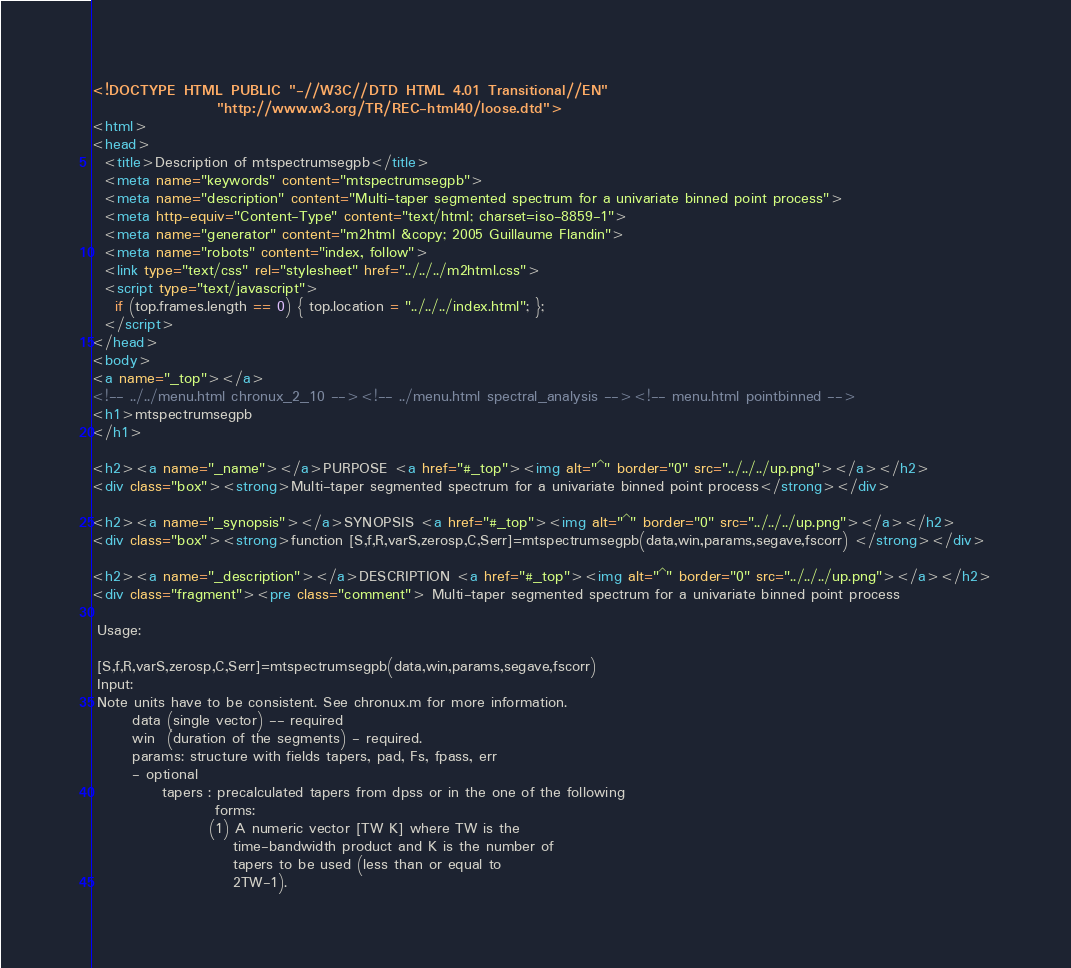Convert code to text. <code><loc_0><loc_0><loc_500><loc_500><_HTML_><!DOCTYPE HTML PUBLIC "-//W3C//DTD HTML 4.01 Transitional//EN"
                "http://www.w3.org/TR/REC-html40/loose.dtd">
<html>
<head>
  <title>Description of mtspectrumsegpb</title>
  <meta name="keywords" content="mtspectrumsegpb">
  <meta name="description" content="Multi-taper segmented spectrum for a univariate binned point process">
  <meta http-equiv="Content-Type" content="text/html; charset=iso-8859-1">
  <meta name="generator" content="m2html &copy; 2005 Guillaume Flandin">
  <meta name="robots" content="index, follow">
  <link type="text/css" rel="stylesheet" href="../../../m2html.css">
  <script type="text/javascript">
    if (top.frames.length == 0) { top.location = "../../../index.html"; };
  </script>
</head>
<body>
<a name="_top"></a>
<!-- ../../menu.html chronux_2_10 --><!-- ../menu.html spectral_analysis --><!-- menu.html pointbinned -->
<h1>mtspectrumsegpb
</h1>

<h2><a name="_name"></a>PURPOSE <a href="#_top"><img alt="^" border="0" src="../../../up.png"></a></h2>
<div class="box"><strong>Multi-taper segmented spectrum for a univariate binned point process</strong></div>

<h2><a name="_synopsis"></a>SYNOPSIS <a href="#_top"><img alt="^" border="0" src="../../../up.png"></a></h2>
<div class="box"><strong>function [S,f,R,varS,zerosp,C,Serr]=mtspectrumsegpb(data,win,params,segave,fscorr) </strong></div>

<h2><a name="_description"></a>DESCRIPTION <a href="#_top"><img alt="^" border="0" src="../../../up.png"></a></h2>
<div class="fragment"><pre class="comment"> Multi-taper segmented spectrum for a univariate binned point process

 Usage:

 [S,f,R,varS,zerosp,C,Serr]=mtspectrumsegpb(data,win,params,segave,fscorr)
 Input: 
 Note units have to be consistent. See chronux.m for more information.
       data (single vector) -- required
       win  (duration of the segments) - required. 
       params: structure with fields tapers, pad, Fs, fpass, err
       - optional
            tapers : precalculated tapers from dpss or in the one of the following
                     forms: 
                    (1) A numeric vector [TW K] where TW is the
                        time-bandwidth product and K is the number of
                        tapers to be used (less than or equal to
                        2TW-1). </code> 